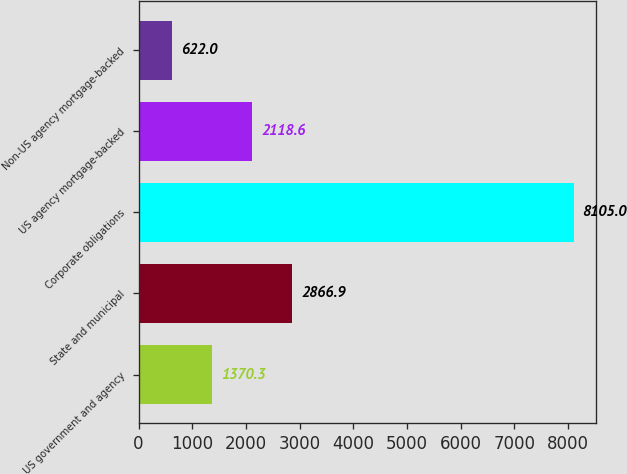<chart> <loc_0><loc_0><loc_500><loc_500><bar_chart><fcel>US government and agency<fcel>State and municipal<fcel>Corporate obligations<fcel>US agency mortgage-backed<fcel>Non-US agency mortgage-backed<nl><fcel>1370.3<fcel>2866.9<fcel>8105<fcel>2118.6<fcel>622<nl></chart> 